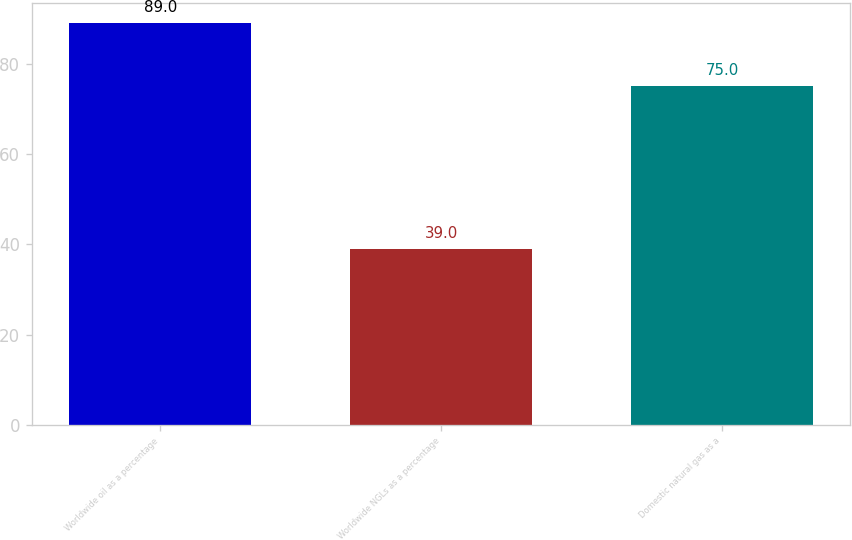Convert chart. <chart><loc_0><loc_0><loc_500><loc_500><bar_chart><fcel>Worldwide oil as a percentage<fcel>Worldwide NGLs as a percentage<fcel>Domestic natural gas as a<nl><fcel>89<fcel>39<fcel>75<nl></chart> 